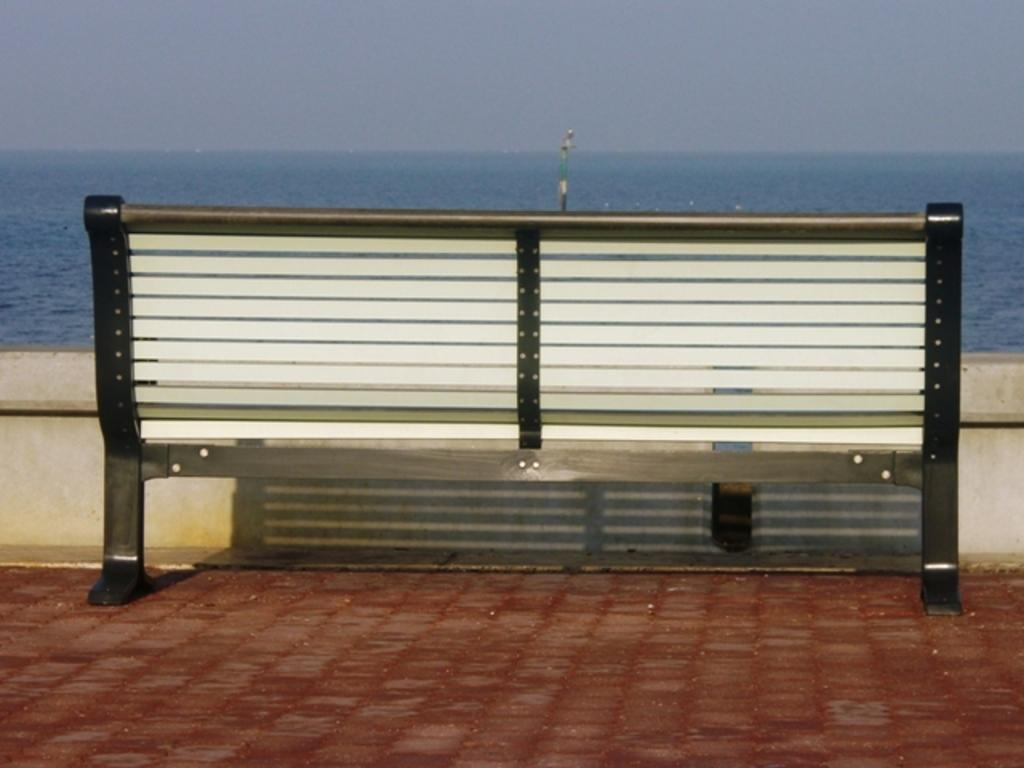What type of seating is present in the image? There is a bench on the ground in the image. What is located in front of the bench? There is a wall in front of the bench. What can be seen behind the wall? Water is visible behind the wall. What is visible at the top of the image? The sky is visible at the top of the image. What type of nation is depicted in the image? There is no nation depicted in the image; it features a bench, a wall, water, and the sky. Can you see a monkey in the image? There is no monkey present in the image. 